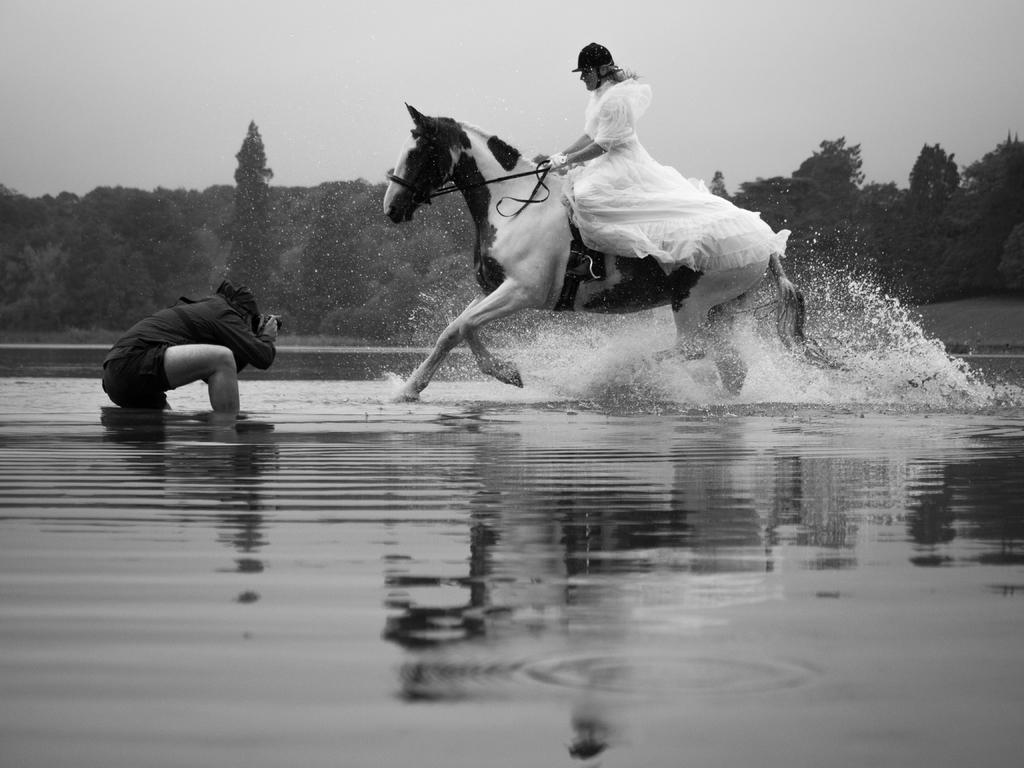What is the woman doing in the image? The woman is riding a horse in the image. What is unique about the location of the woman and horse? They are in the water. What is the person with a camera doing in the image? The person is taking a picture. What can be seen in the background of the image? There are trees and the sky visible in the background. What level of difficulty is the woman's partner experiencing while attempting to lift the horse out of the water? There is no partner or lifting of the horse in the image; the woman is simply riding the horse in the water. 